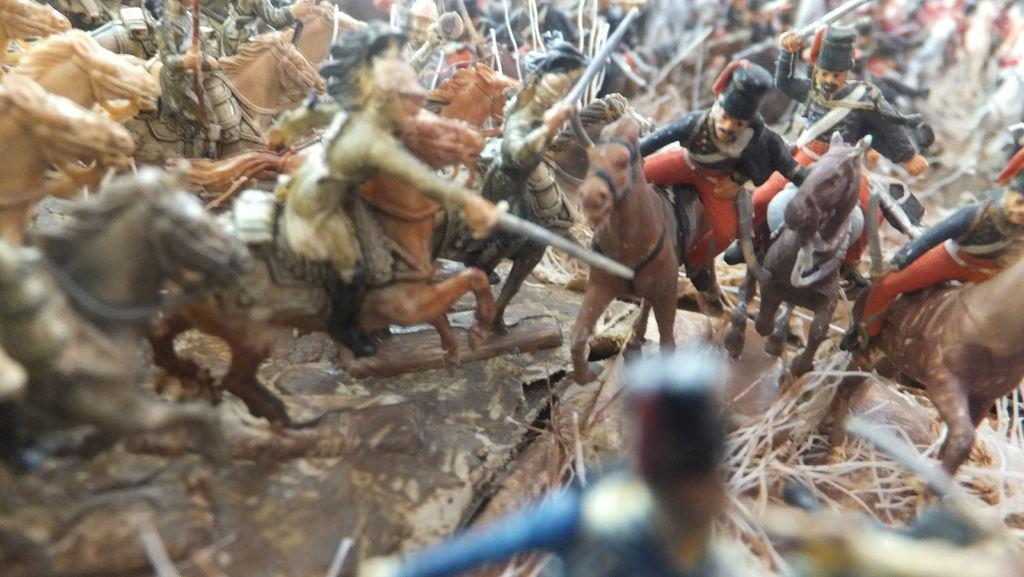What type of toys are on the ground in the image? There are toys on the ground in the image, specifically human toys and horse toys. What are the human toys doing in the image? The human toys are sitting on horse toys in the image. What are the human toys holding in their hands? The human toys are holding swords in their hands in the image. Can you hear the voice of the toy sack in the image? There is no toy sack present in the image, and therefore no voice can be heard. 